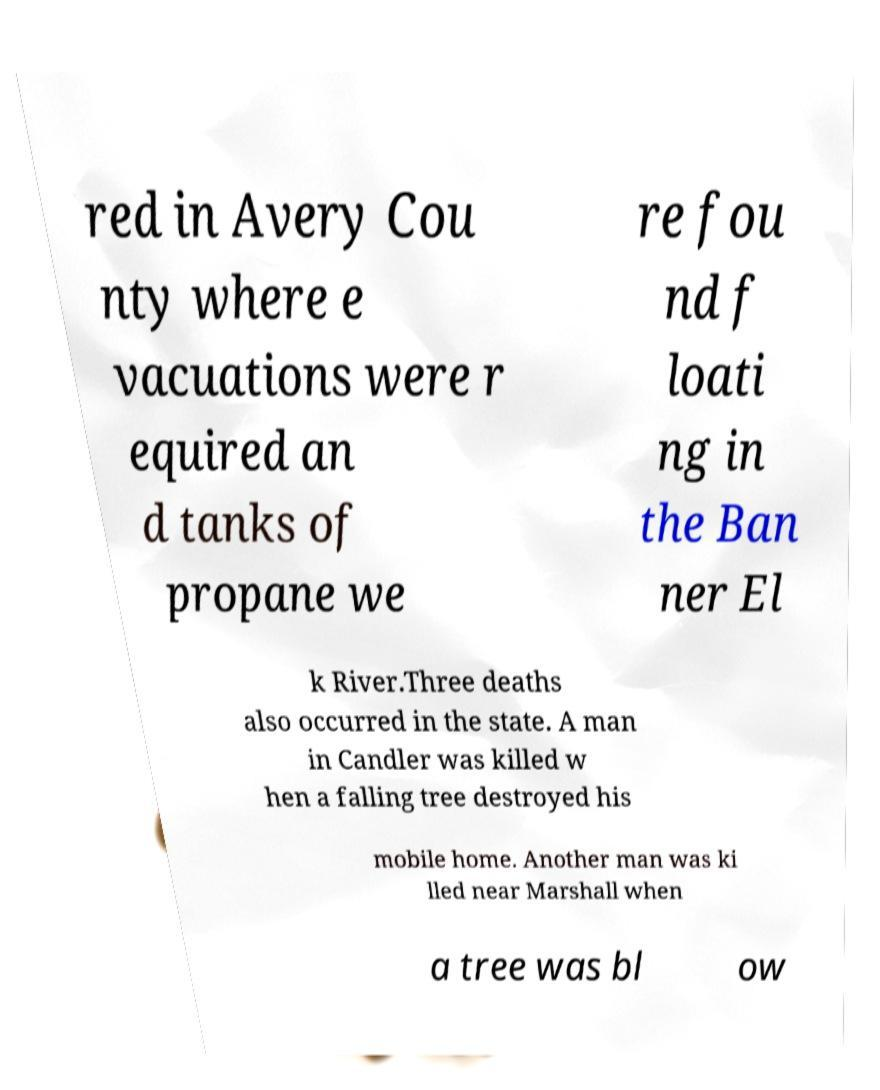For documentation purposes, I need the text within this image transcribed. Could you provide that? red in Avery Cou nty where e vacuations were r equired an d tanks of propane we re fou nd f loati ng in the Ban ner El k River.Three deaths also occurred in the state. A man in Candler was killed w hen a falling tree destroyed his mobile home. Another man was ki lled near Marshall when a tree was bl ow 